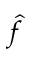<formula> <loc_0><loc_0><loc_500><loc_500>\hat { f }</formula> 